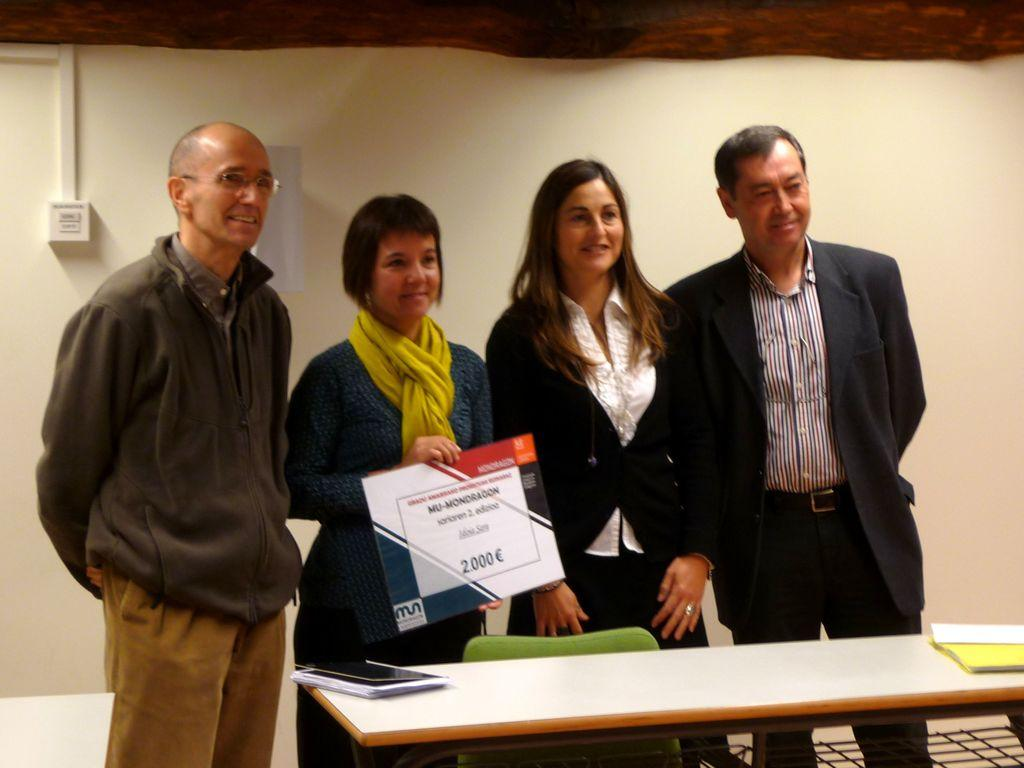What is happening in the image? There are people standing in the image. Can you describe what one of the people is holding? A woman is holding a photo frame in her hand. What type of pie is being served with a fork in the image? There is no pie or fork present in the image. 